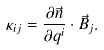<formula> <loc_0><loc_0><loc_500><loc_500>\kappa _ { i j } = \frac { \partial \vec { n } } { \partial q ^ { i } } \cdot \vec { B } _ { j } .</formula> 